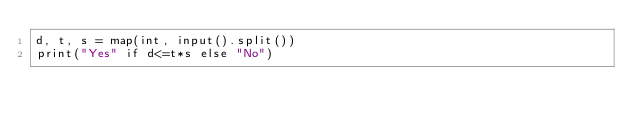<code> <loc_0><loc_0><loc_500><loc_500><_Python_>d, t, s = map(int, input().split())
print("Yes" if d<=t*s else "No")</code> 